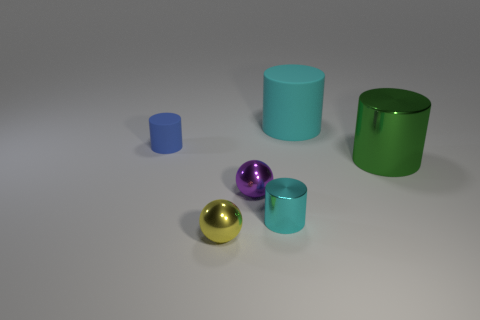What number of objects are green things or big rubber cylinders?
Provide a short and direct response. 2. What number of things are either small blue metal spheres or cylinders that are to the right of the cyan shiny object?
Make the answer very short. 2. Are the blue thing and the tiny purple sphere made of the same material?
Your answer should be compact. No. What number of other objects are the same material as the large cyan object?
Your response must be concise. 1. Are there more tiny blue cylinders than metallic objects?
Your answer should be compact. No. There is a object that is on the left side of the tiny yellow shiny thing; is it the same shape as the tiny cyan object?
Your answer should be very brief. Yes. Is the number of blue objects less than the number of large gray metallic objects?
Make the answer very short. No. There is a purple object that is the same size as the blue matte cylinder; what is its material?
Your answer should be compact. Metal. There is a big metal cylinder; does it have the same color as the large object that is behind the large green thing?
Provide a succinct answer. No. Are there fewer big green cylinders in front of the small yellow object than yellow objects?
Ensure brevity in your answer.  Yes. 